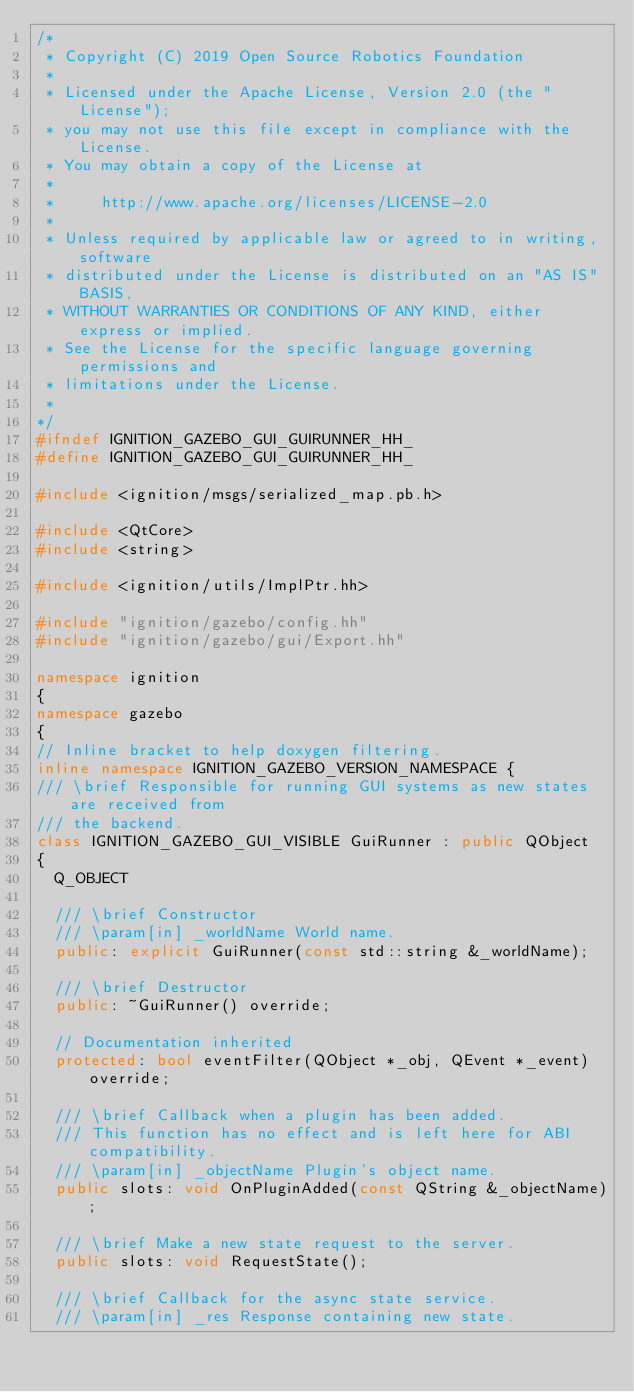<code> <loc_0><loc_0><loc_500><loc_500><_C++_>/*
 * Copyright (C) 2019 Open Source Robotics Foundation
 *
 * Licensed under the Apache License, Version 2.0 (the "License");
 * you may not use this file except in compliance with the License.
 * You may obtain a copy of the License at
 *
 *     http://www.apache.org/licenses/LICENSE-2.0
 *
 * Unless required by applicable law or agreed to in writing, software
 * distributed under the License is distributed on an "AS IS" BASIS,
 * WITHOUT WARRANTIES OR CONDITIONS OF ANY KIND, either express or implied.
 * See the License for the specific language governing permissions and
 * limitations under the License.
 *
*/
#ifndef IGNITION_GAZEBO_GUI_GUIRUNNER_HH_
#define IGNITION_GAZEBO_GUI_GUIRUNNER_HH_

#include <ignition/msgs/serialized_map.pb.h>

#include <QtCore>
#include <string>

#include <ignition/utils/ImplPtr.hh>

#include "ignition/gazebo/config.hh"
#include "ignition/gazebo/gui/Export.hh"

namespace ignition
{
namespace gazebo
{
// Inline bracket to help doxygen filtering.
inline namespace IGNITION_GAZEBO_VERSION_NAMESPACE {
/// \brief Responsible for running GUI systems as new states are received from
/// the backend.
class IGNITION_GAZEBO_GUI_VISIBLE GuiRunner : public QObject
{
  Q_OBJECT

  /// \brief Constructor
  /// \param[in] _worldName World name.
  public: explicit GuiRunner(const std::string &_worldName);

  /// \brief Destructor
  public: ~GuiRunner() override;

  // Documentation inherited
  protected: bool eventFilter(QObject *_obj, QEvent *_event) override;

  /// \brief Callback when a plugin has been added.
  /// This function has no effect and is left here for ABI compatibility.
  /// \param[in] _objectName Plugin's object name.
  public slots: void OnPluginAdded(const QString &_objectName);

  /// \brief Make a new state request to the server.
  public slots: void RequestState();

  /// \brief Callback for the async state service.
  /// \param[in] _res Response containing new state.</code> 